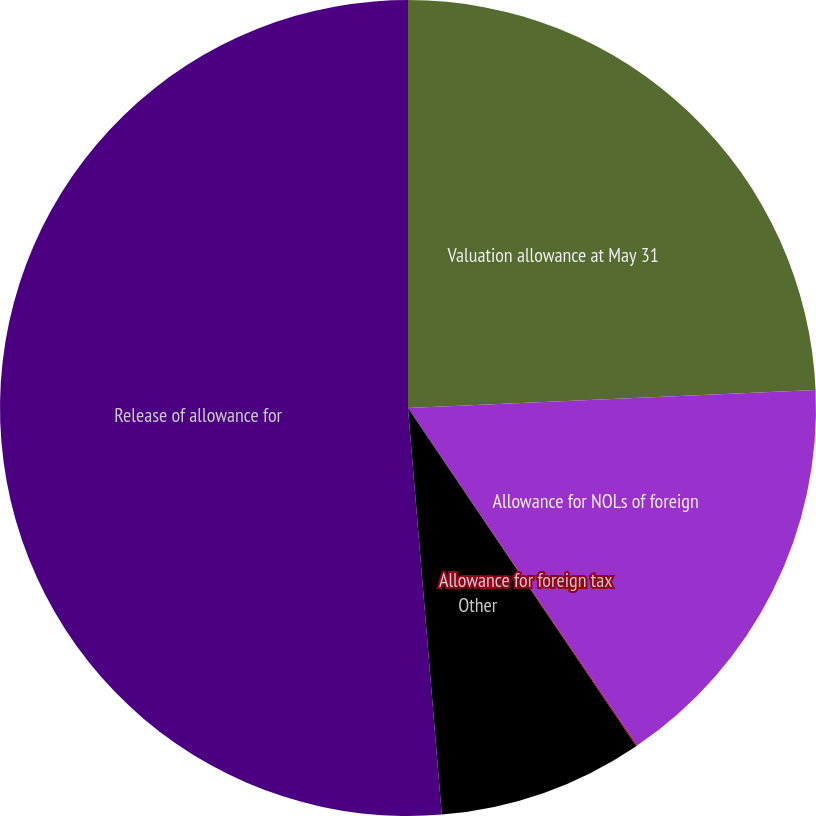<chart> <loc_0><loc_0><loc_500><loc_500><pie_chart><fcel>Valuation allowance at May 31<fcel>Allowance for NOLs of foreign<fcel>Allowance for foreign tax<fcel>Other<fcel>Release of allowance for<nl><fcel>24.3%<fcel>16.21%<fcel>0.04%<fcel>8.13%<fcel>51.32%<nl></chart> 